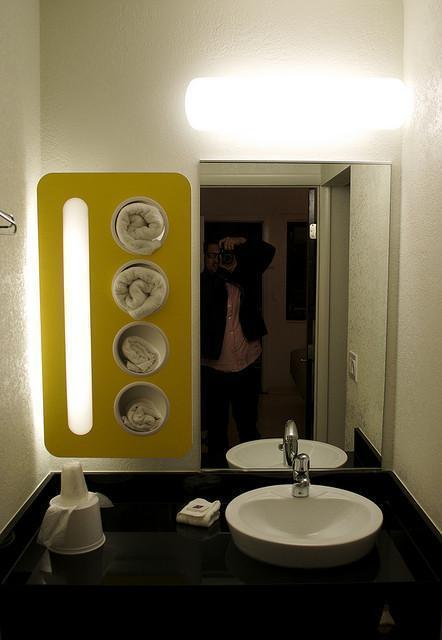What is near the sink?
Make your selection and explain in format: 'Answer: answer
Rationale: rationale.'
Options: Towel, badger, baby, cat. Answer: towel.
Rationale: A hand towel is near the sink to dry your hands on. 